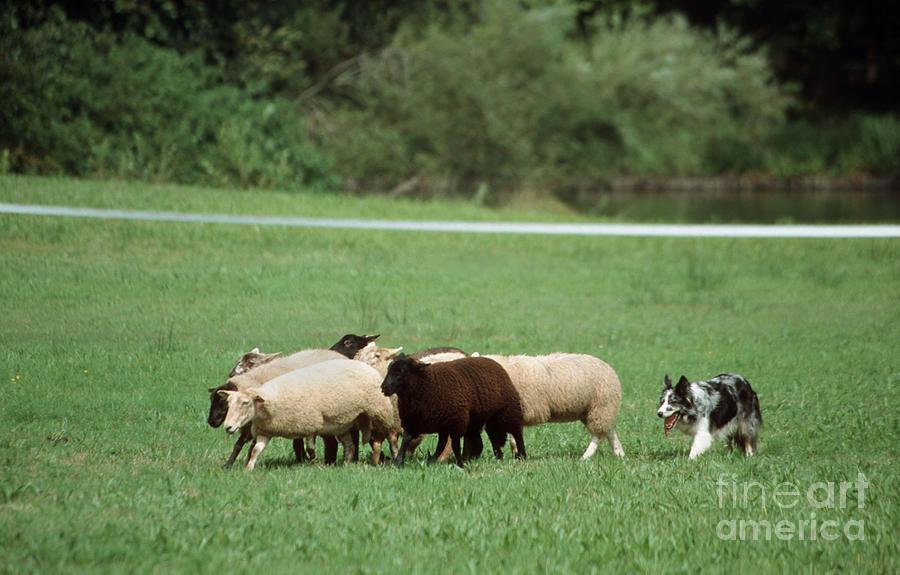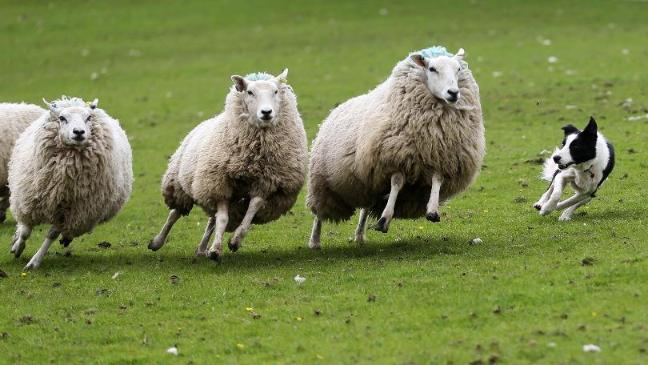The first image is the image on the left, the second image is the image on the right. For the images shown, is this caption "A dog is positioned closest to the front of an image, with multiple sheep in the back." true? Answer yes or no. No. The first image is the image on the left, the second image is the image on the right. Evaluate the accuracy of this statement regarding the images: "In one of the images, there are exactly three sheep.". Is it true? Answer yes or no. Yes. 